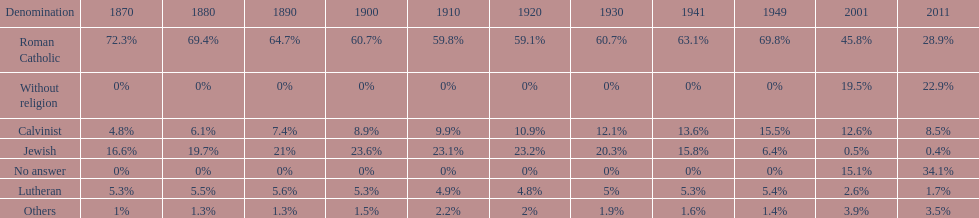How many denominations never dropped below 20%? 1. 